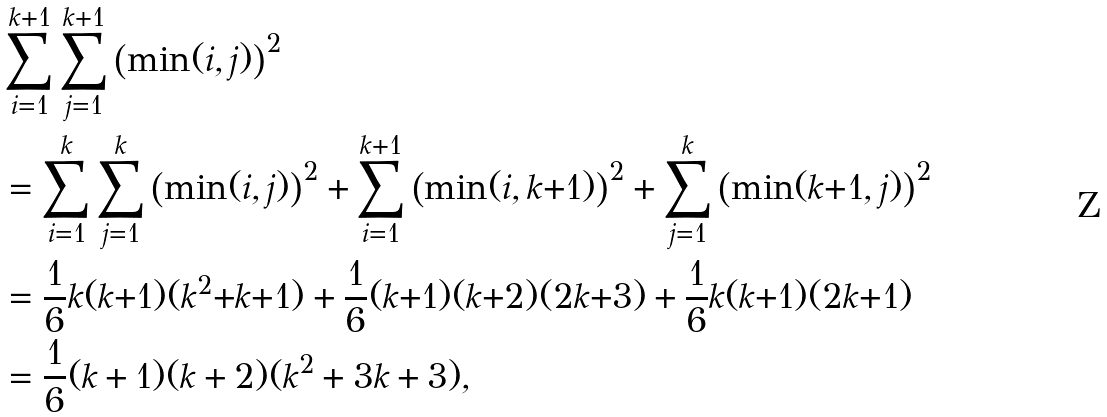Convert formula to latex. <formula><loc_0><loc_0><loc_500><loc_500>& \sum _ { i = 1 } ^ { k + 1 } \sum _ { j = 1 } ^ { k + 1 } \left ( \min ( i , j ) \right ) ^ { 2 } \\ & = \sum _ { i = 1 } ^ { k } \sum _ { j = 1 } ^ { k } \left ( \min ( i , j ) \right ) ^ { 2 } + \sum _ { i = 1 } ^ { k + 1 } \left ( \min ( i , k { + } 1 ) \right ) ^ { 2 } + \sum _ { j = 1 } ^ { k } \left ( \min ( k { + } 1 , j ) \right ) ^ { 2 } \\ & = \frac { 1 } { 6 } k ( k { + } 1 ) ( k ^ { 2 } { + } k { + } 1 ) + \frac { 1 } { 6 } ( k { + } 1 ) ( k { + } 2 ) ( 2 k { + } 3 ) + \frac { 1 } { 6 } k ( k { + } 1 ) ( 2 k { + } 1 ) \\ & = \frac { 1 } { 6 } ( k + 1 ) ( k + 2 ) ( k ^ { 2 } + 3 k + 3 ) ,</formula> 